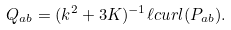Convert formula to latex. <formula><loc_0><loc_0><loc_500><loc_500>Q _ { a b } = ( k ^ { 2 } + 3 K ) ^ { - 1 } \ell c u r l ( P _ { a b } ) .</formula> 